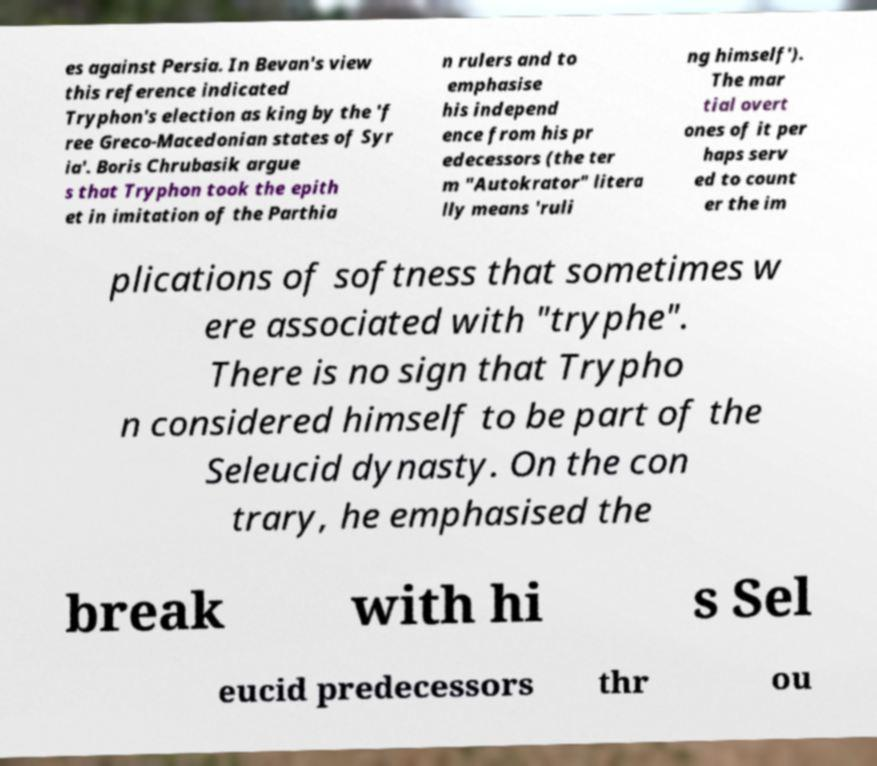Please read and relay the text visible in this image. What does it say? es against Persia. In Bevan's view this reference indicated Tryphon's election as king by the 'f ree Greco-Macedonian states of Syr ia'. Boris Chrubasik argue s that Tryphon took the epith et in imitation of the Parthia n rulers and to emphasise his independ ence from his pr edecessors (the ter m "Autokrator" litera lly means 'ruli ng himself'). The mar tial overt ones of it per haps serv ed to count er the im plications of softness that sometimes w ere associated with "tryphe". There is no sign that Trypho n considered himself to be part of the Seleucid dynasty. On the con trary, he emphasised the break with hi s Sel eucid predecessors thr ou 